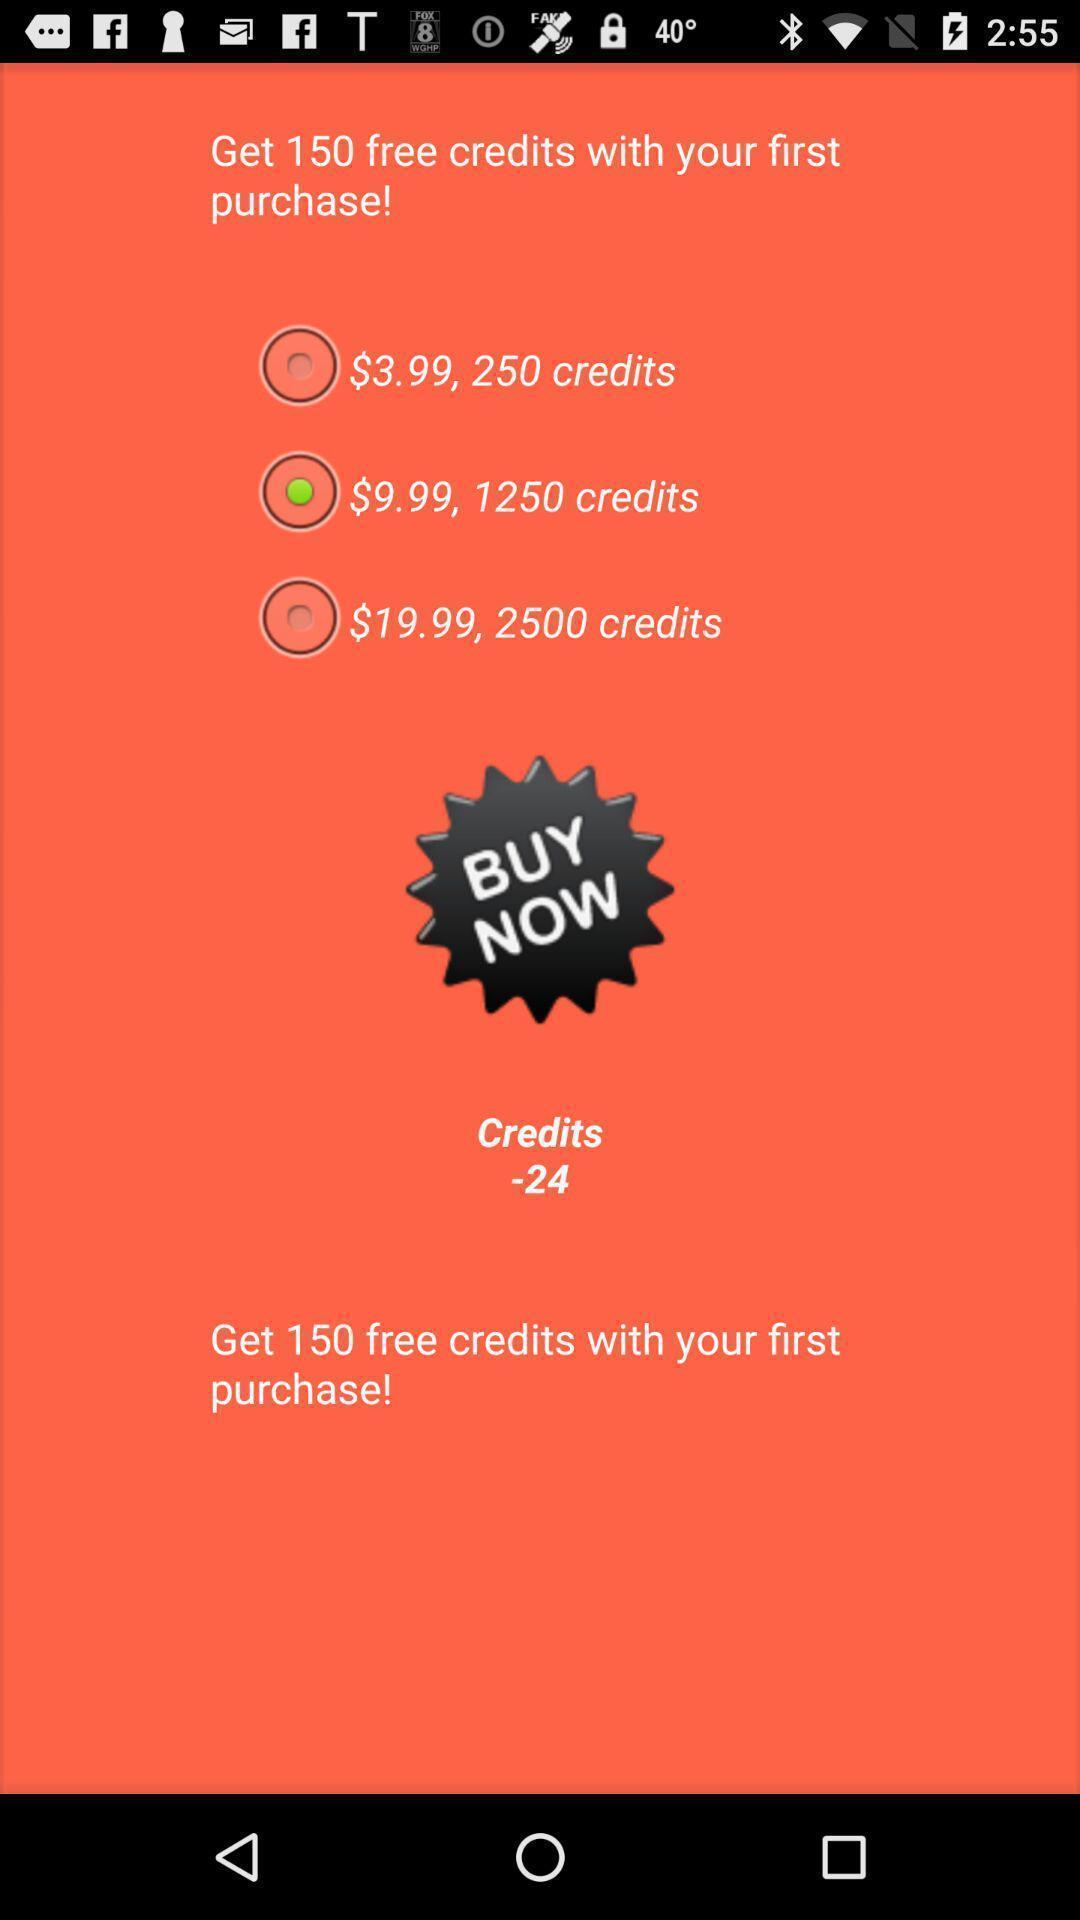What is the overall content of this screenshot? Page displaying various credits offer in a shopping app. 